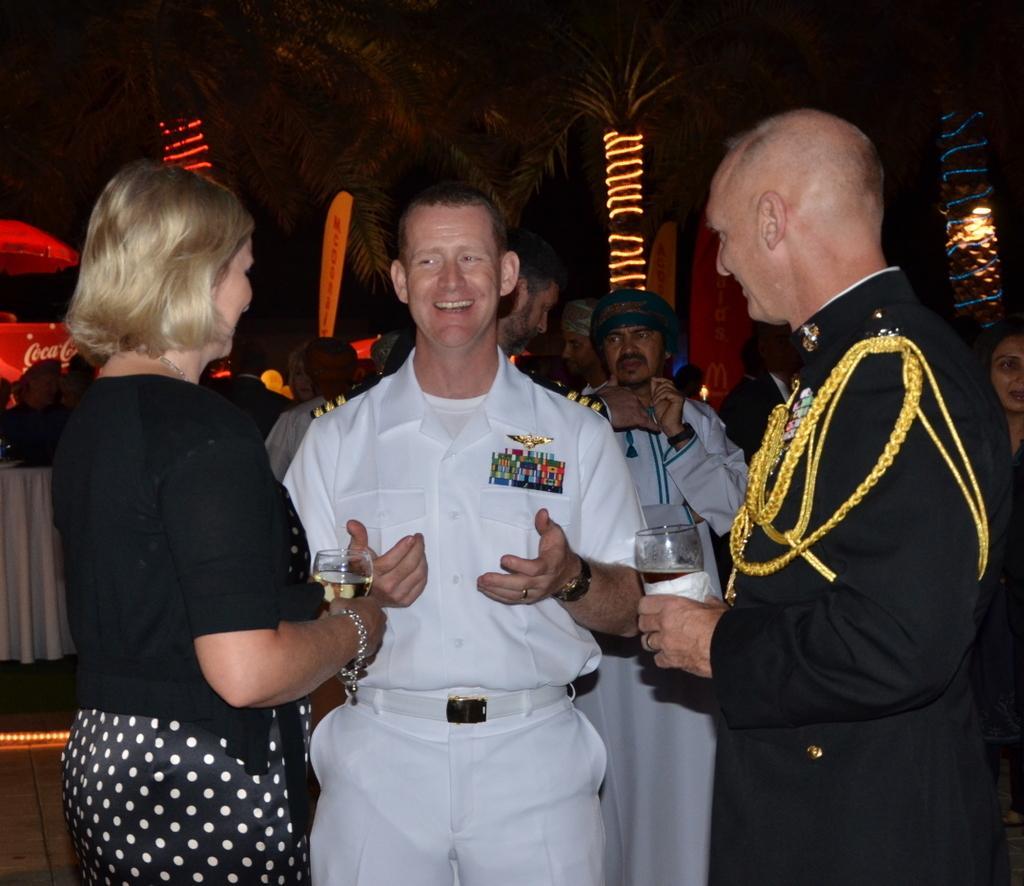Please provide a concise description of this image. In the picture I can see two persons standing and holding a glass of drink in their hands and there is a person wearing white dress is standing in between them and there are few other people behind them and there are trees decorated with few lights in the background. 